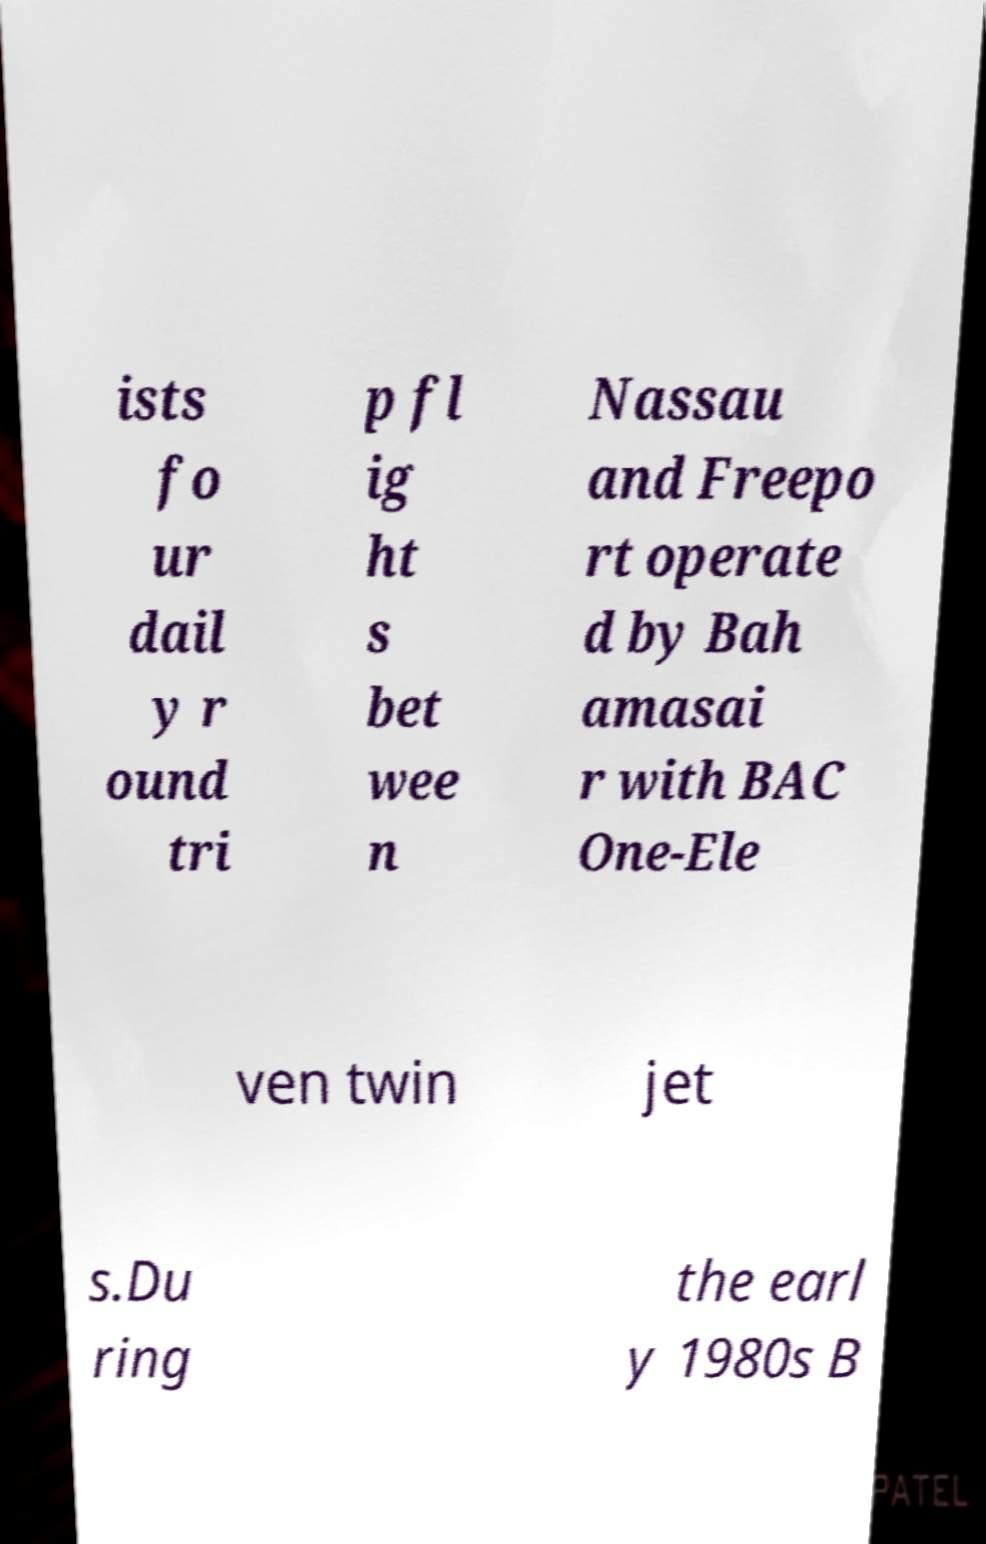What messages or text are displayed in this image? I need them in a readable, typed format. ists fo ur dail y r ound tri p fl ig ht s bet wee n Nassau and Freepo rt operate d by Bah amasai r with BAC One-Ele ven twin jet s.Du ring the earl y 1980s B 